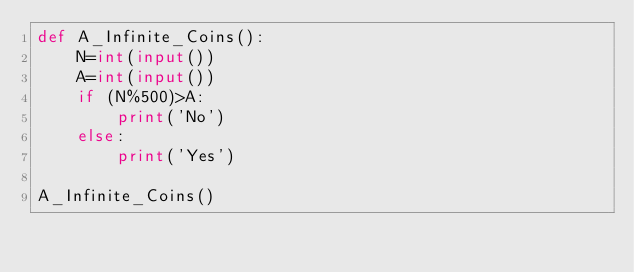<code> <loc_0><loc_0><loc_500><loc_500><_Python_>def A_Infinite_Coins():
    N=int(input())
    A=int(input())
    if (N%500)>A:
        print('No')
    else:
        print('Yes')

A_Infinite_Coins()</code> 